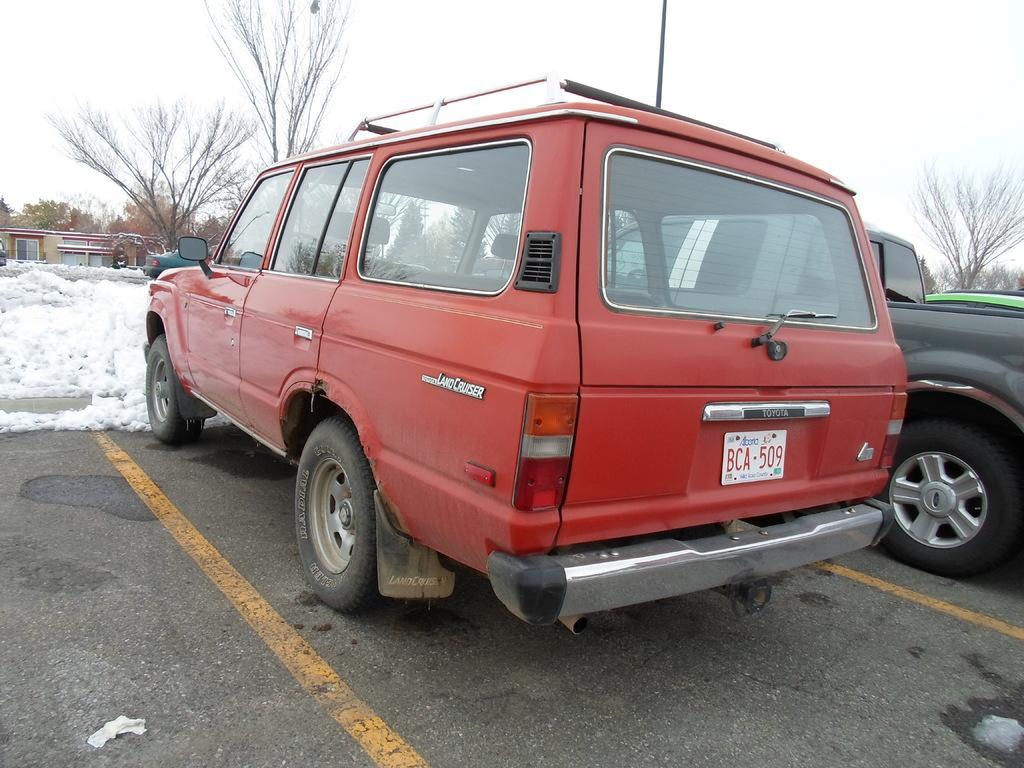Can you describe this image briefly? In the middle of the image we can see some vehicles on the road. Behind the vehicles we can see snow, trees and pole. At the top of the image we can see the sky. 